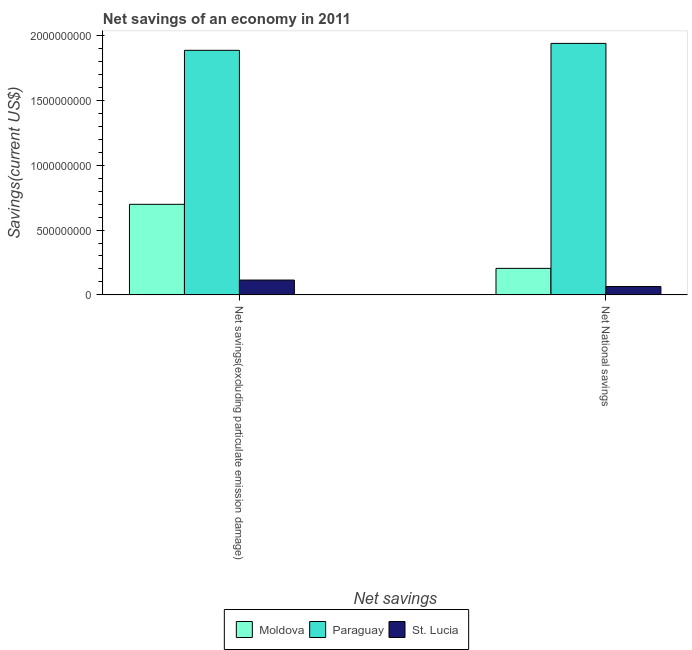How many different coloured bars are there?
Provide a succinct answer. 3. Are the number of bars per tick equal to the number of legend labels?
Offer a very short reply. Yes. Are the number of bars on each tick of the X-axis equal?
Provide a succinct answer. Yes. How many bars are there on the 2nd tick from the right?
Keep it short and to the point. 3. What is the label of the 1st group of bars from the left?
Your answer should be compact. Net savings(excluding particulate emission damage). What is the net savings(excluding particulate emission damage) in Paraguay?
Offer a very short reply. 1.89e+09. Across all countries, what is the maximum net savings(excluding particulate emission damage)?
Provide a succinct answer. 1.89e+09. Across all countries, what is the minimum net savings(excluding particulate emission damage)?
Your answer should be very brief. 1.14e+08. In which country was the net savings(excluding particulate emission damage) maximum?
Provide a succinct answer. Paraguay. In which country was the net national savings minimum?
Offer a terse response. St. Lucia. What is the total net savings(excluding particulate emission damage) in the graph?
Ensure brevity in your answer.  2.70e+09. What is the difference between the net savings(excluding particulate emission damage) in St. Lucia and that in Paraguay?
Provide a succinct answer. -1.77e+09. What is the difference between the net national savings in St. Lucia and the net savings(excluding particulate emission damage) in Moldova?
Keep it short and to the point. -6.34e+08. What is the average net national savings per country?
Your response must be concise. 7.36e+08. What is the difference between the net savings(excluding particulate emission damage) and net national savings in Moldova?
Ensure brevity in your answer.  4.94e+08. In how many countries, is the net national savings greater than 1800000000 US$?
Keep it short and to the point. 1. What is the ratio of the net savings(excluding particulate emission damage) in St. Lucia to that in Paraguay?
Keep it short and to the point. 0.06. Is the net national savings in Paraguay less than that in St. Lucia?
Provide a short and direct response. No. In how many countries, is the net national savings greater than the average net national savings taken over all countries?
Your response must be concise. 1. What does the 3rd bar from the left in Net savings(excluding particulate emission damage) represents?
Your answer should be compact. St. Lucia. What does the 2nd bar from the right in Net National savings represents?
Provide a succinct answer. Paraguay. Does the graph contain grids?
Provide a succinct answer. No. Where does the legend appear in the graph?
Provide a succinct answer. Bottom center. How many legend labels are there?
Ensure brevity in your answer.  3. What is the title of the graph?
Offer a terse response. Net savings of an economy in 2011. What is the label or title of the X-axis?
Provide a succinct answer. Net savings. What is the label or title of the Y-axis?
Give a very brief answer. Savings(current US$). What is the Savings(current US$) in Moldova in Net savings(excluding particulate emission damage)?
Provide a short and direct response. 6.98e+08. What is the Savings(current US$) in Paraguay in Net savings(excluding particulate emission damage)?
Provide a short and direct response. 1.89e+09. What is the Savings(current US$) in St. Lucia in Net savings(excluding particulate emission damage)?
Offer a terse response. 1.14e+08. What is the Savings(current US$) in Moldova in Net National savings?
Provide a succinct answer. 2.04e+08. What is the Savings(current US$) of Paraguay in Net National savings?
Offer a very short reply. 1.94e+09. What is the Savings(current US$) in St. Lucia in Net National savings?
Your answer should be compact. 6.44e+07. Across all Net savings, what is the maximum Savings(current US$) of Moldova?
Make the answer very short. 6.98e+08. Across all Net savings, what is the maximum Savings(current US$) of Paraguay?
Offer a very short reply. 1.94e+09. Across all Net savings, what is the maximum Savings(current US$) of St. Lucia?
Your answer should be very brief. 1.14e+08. Across all Net savings, what is the minimum Savings(current US$) of Moldova?
Provide a succinct answer. 2.04e+08. Across all Net savings, what is the minimum Savings(current US$) of Paraguay?
Ensure brevity in your answer.  1.89e+09. Across all Net savings, what is the minimum Savings(current US$) of St. Lucia?
Your answer should be compact. 6.44e+07. What is the total Savings(current US$) in Moldova in the graph?
Offer a very short reply. 9.03e+08. What is the total Savings(current US$) of Paraguay in the graph?
Your answer should be very brief. 3.82e+09. What is the total Savings(current US$) in St. Lucia in the graph?
Your answer should be very brief. 1.79e+08. What is the difference between the Savings(current US$) of Moldova in Net savings(excluding particulate emission damage) and that in Net National savings?
Provide a short and direct response. 4.94e+08. What is the difference between the Savings(current US$) in Paraguay in Net savings(excluding particulate emission damage) and that in Net National savings?
Your answer should be compact. -5.33e+07. What is the difference between the Savings(current US$) in St. Lucia in Net savings(excluding particulate emission damage) and that in Net National savings?
Provide a succinct answer. 5.00e+07. What is the difference between the Savings(current US$) in Moldova in Net savings(excluding particulate emission damage) and the Savings(current US$) in Paraguay in Net National savings?
Your answer should be compact. -1.24e+09. What is the difference between the Savings(current US$) of Moldova in Net savings(excluding particulate emission damage) and the Savings(current US$) of St. Lucia in Net National savings?
Your answer should be compact. 6.34e+08. What is the difference between the Savings(current US$) of Paraguay in Net savings(excluding particulate emission damage) and the Savings(current US$) of St. Lucia in Net National savings?
Provide a short and direct response. 1.82e+09. What is the average Savings(current US$) in Moldova per Net savings?
Ensure brevity in your answer.  4.51e+08. What is the average Savings(current US$) in Paraguay per Net savings?
Offer a very short reply. 1.91e+09. What is the average Savings(current US$) of St. Lucia per Net savings?
Your answer should be compact. 8.94e+07. What is the difference between the Savings(current US$) of Moldova and Savings(current US$) of Paraguay in Net savings(excluding particulate emission damage)?
Offer a terse response. -1.19e+09. What is the difference between the Savings(current US$) of Moldova and Savings(current US$) of St. Lucia in Net savings(excluding particulate emission damage)?
Offer a terse response. 5.84e+08. What is the difference between the Savings(current US$) in Paraguay and Savings(current US$) in St. Lucia in Net savings(excluding particulate emission damage)?
Give a very brief answer. 1.77e+09. What is the difference between the Savings(current US$) of Moldova and Savings(current US$) of Paraguay in Net National savings?
Provide a succinct answer. -1.73e+09. What is the difference between the Savings(current US$) of Moldova and Savings(current US$) of St. Lucia in Net National savings?
Ensure brevity in your answer.  1.40e+08. What is the difference between the Savings(current US$) in Paraguay and Savings(current US$) in St. Lucia in Net National savings?
Provide a succinct answer. 1.87e+09. What is the ratio of the Savings(current US$) in Moldova in Net savings(excluding particulate emission damage) to that in Net National savings?
Make the answer very short. 3.41. What is the ratio of the Savings(current US$) of Paraguay in Net savings(excluding particulate emission damage) to that in Net National savings?
Your answer should be compact. 0.97. What is the ratio of the Savings(current US$) of St. Lucia in Net savings(excluding particulate emission damage) to that in Net National savings?
Provide a short and direct response. 1.78. What is the difference between the highest and the second highest Savings(current US$) in Moldova?
Offer a very short reply. 4.94e+08. What is the difference between the highest and the second highest Savings(current US$) of Paraguay?
Offer a very short reply. 5.33e+07. What is the difference between the highest and the second highest Savings(current US$) of St. Lucia?
Your answer should be compact. 5.00e+07. What is the difference between the highest and the lowest Savings(current US$) in Moldova?
Your response must be concise. 4.94e+08. What is the difference between the highest and the lowest Savings(current US$) in Paraguay?
Give a very brief answer. 5.33e+07. What is the difference between the highest and the lowest Savings(current US$) of St. Lucia?
Give a very brief answer. 5.00e+07. 